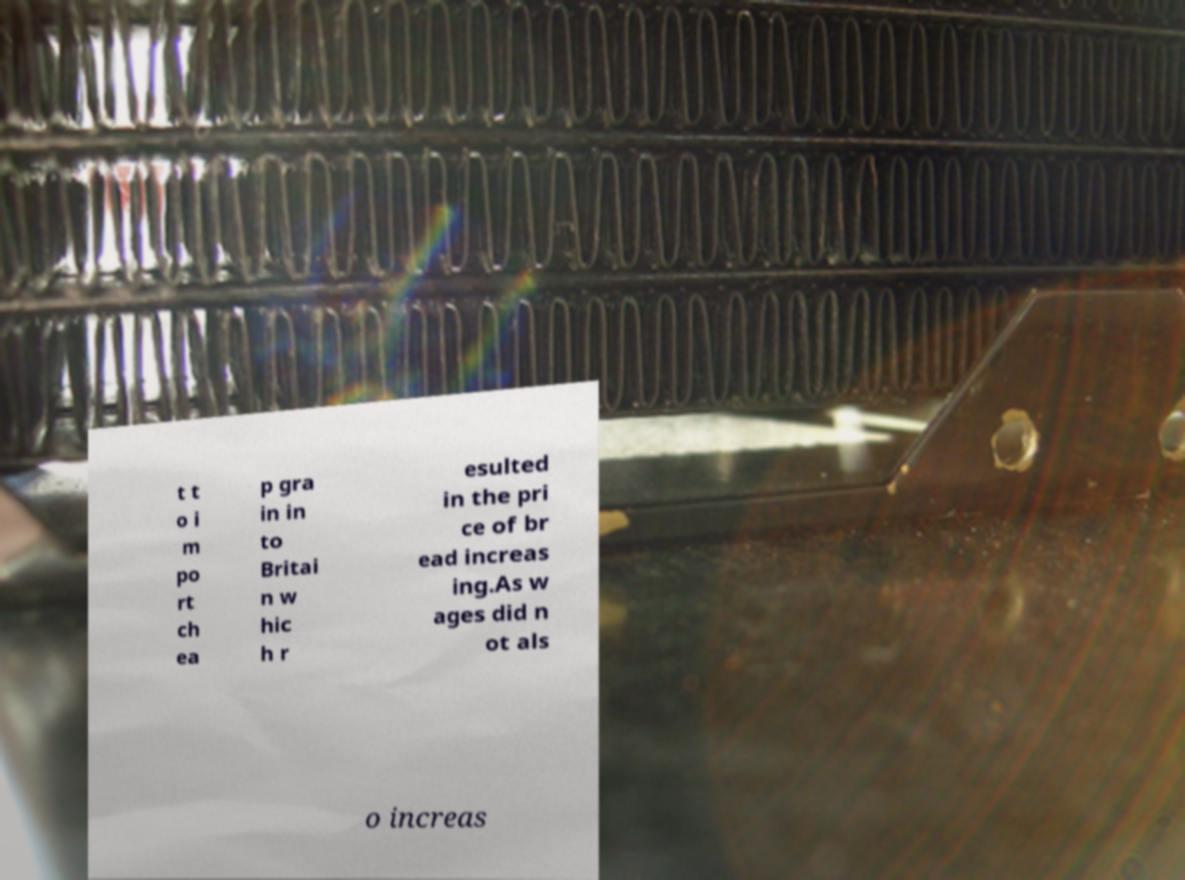Please identify and transcribe the text found in this image. t t o i m po rt ch ea p gra in in to Britai n w hic h r esulted in the pri ce of br ead increas ing.As w ages did n ot als o increas 